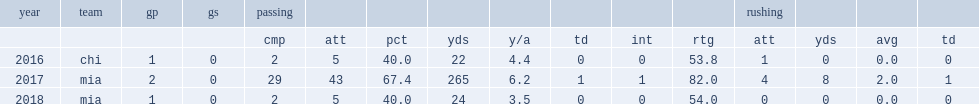How many passing touchdown did fales complete in 2017? 1.0. 